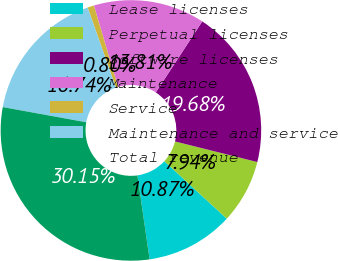Convert chart. <chart><loc_0><loc_0><loc_500><loc_500><pie_chart><fcel>Lease licenses<fcel>Perpetual licenses<fcel>Software licenses<fcel>Maintenance<fcel>Service<fcel>Maintenance and service<fcel>Total revenue<nl><fcel>10.87%<fcel>7.94%<fcel>19.68%<fcel>13.81%<fcel>0.8%<fcel>16.74%<fcel>30.15%<nl></chart> 